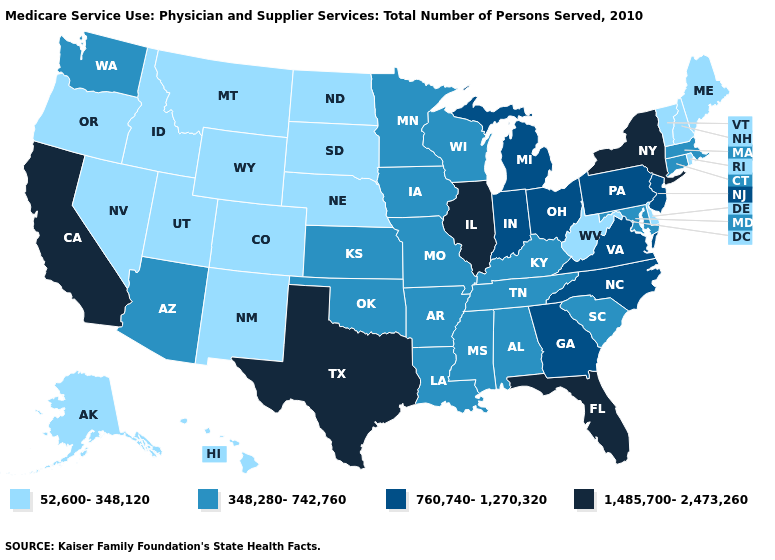Does Missouri have the lowest value in the USA?
Give a very brief answer. No. What is the lowest value in states that border Tennessee?
Quick response, please. 348,280-742,760. Name the states that have a value in the range 760,740-1,270,320?
Answer briefly. Georgia, Indiana, Michigan, New Jersey, North Carolina, Ohio, Pennsylvania, Virginia. What is the highest value in the MidWest ?
Keep it brief. 1,485,700-2,473,260. How many symbols are there in the legend?
Give a very brief answer. 4. What is the value of Georgia?
Short answer required. 760,740-1,270,320. What is the value of Iowa?
Short answer required. 348,280-742,760. What is the value of Washington?
Answer briefly. 348,280-742,760. How many symbols are there in the legend?
Give a very brief answer. 4. Name the states that have a value in the range 52,600-348,120?
Give a very brief answer. Alaska, Colorado, Delaware, Hawaii, Idaho, Maine, Montana, Nebraska, Nevada, New Hampshire, New Mexico, North Dakota, Oregon, Rhode Island, South Dakota, Utah, Vermont, West Virginia, Wyoming. What is the lowest value in the USA?
Short answer required. 52,600-348,120. What is the value of Indiana?
Keep it brief. 760,740-1,270,320. Name the states that have a value in the range 760,740-1,270,320?
Write a very short answer. Georgia, Indiana, Michigan, New Jersey, North Carolina, Ohio, Pennsylvania, Virginia. Name the states that have a value in the range 52,600-348,120?
Keep it brief. Alaska, Colorado, Delaware, Hawaii, Idaho, Maine, Montana, Nebraska, Nevada, New Hampshire, New Mexico, North Dakota, Oregon, Rhode Island, South Dakota, Utah, Vermont, West Virginia, Wyoming. Name the states that have a value in the range 1,485,700-2,473,260?
Give a very brief answer. California, Florida, Illinois, New York, Texas. 